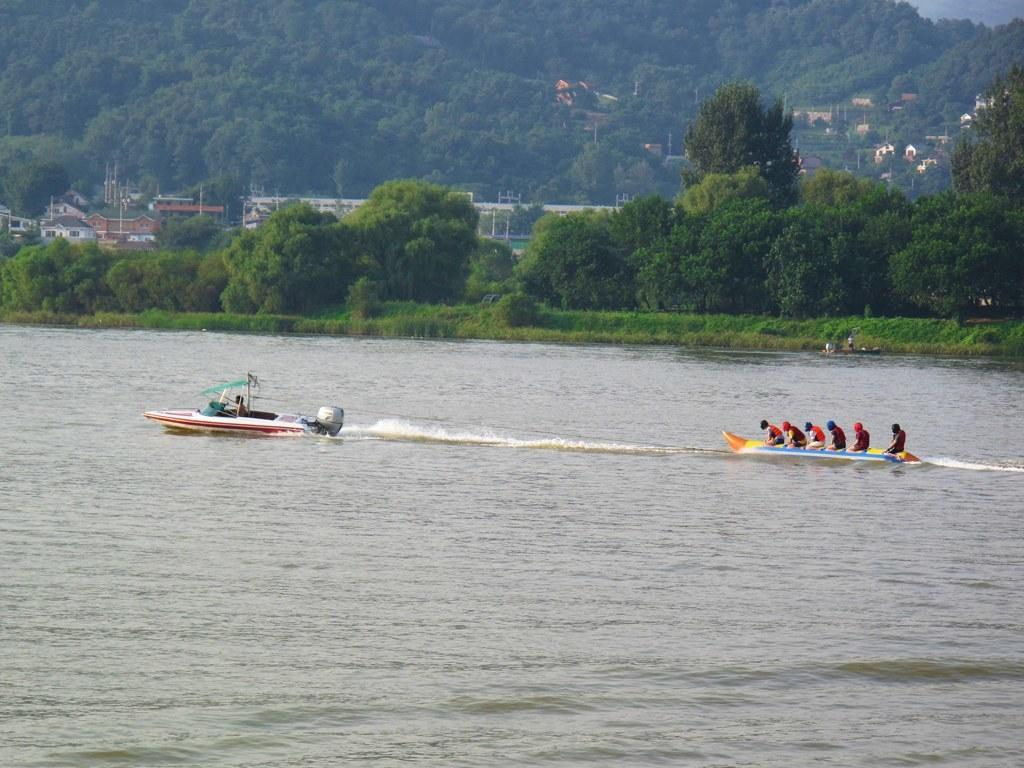Where was the picture taken? The picture was clicked outside the city. What is the main subject of the image? There is a group of persons in a sailboat in the center of the image. What type of landscape is visible in the image? There is a water body, plants, trees, and grass visible in the image. Are there any structures present in the image? Houses are present in the image. What type of cave can be seen in the image? There is no cave present in the image. What color is the zipper on the sailboat in the image? There is no zipper visible on the sailboat in the image. 